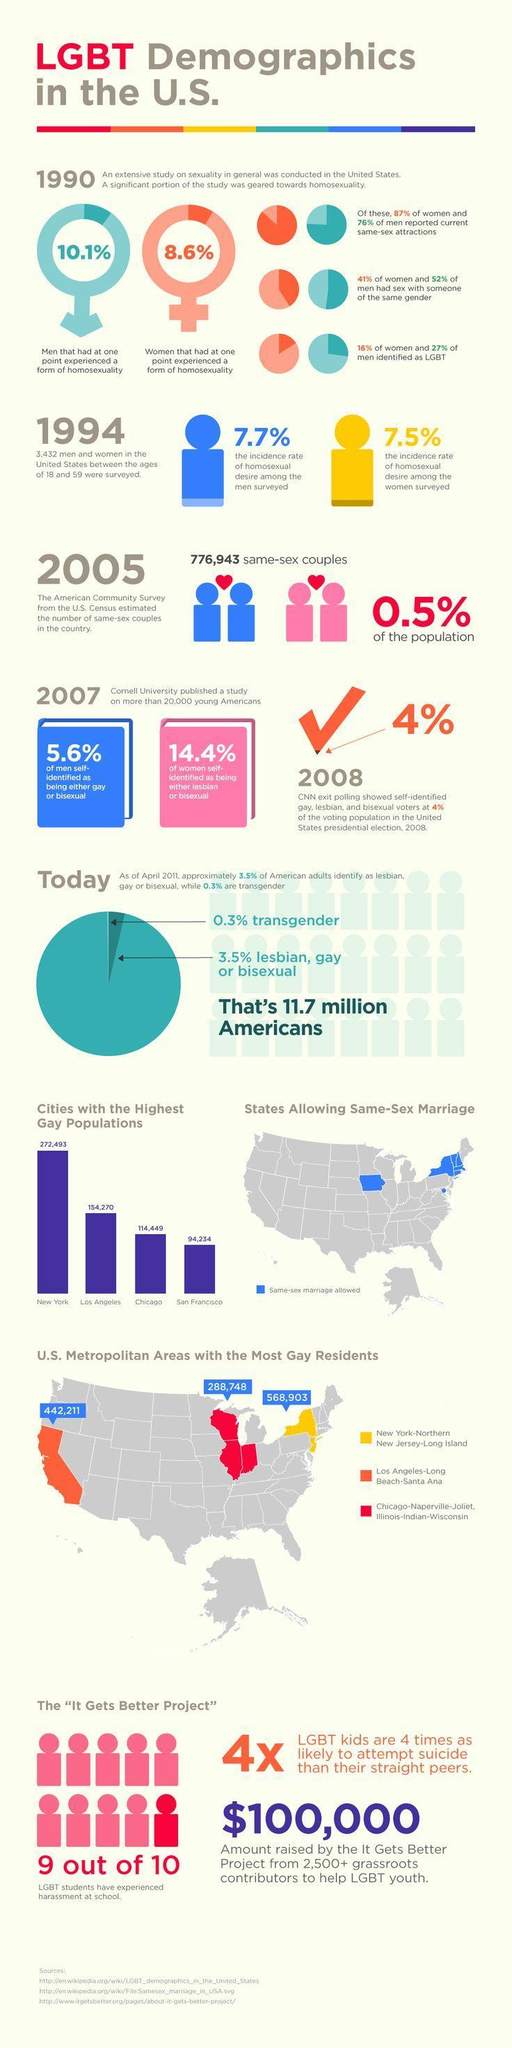How many Americans are either lesbian, gay, bisexual or transgender?
Answer the question with a short phrase. 11.7 million Which area has the most number of gay residents in the US? New York-Northern New Jersey-Long Island Which city has second highest gay population? Los Angeles What percentage of population is same-sex couples? 0.5% 